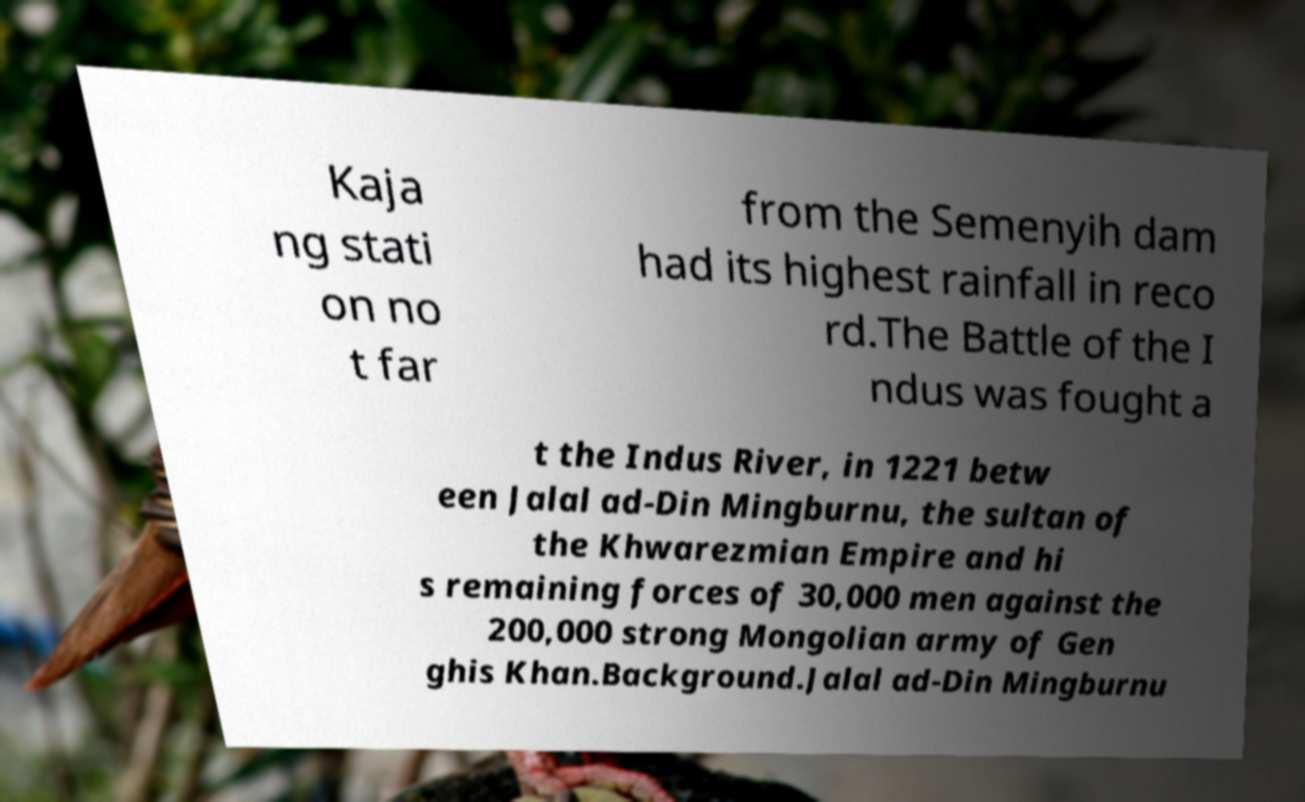I need the written content from this picture converted into text. Can you do that? Kaja ng stati on no t far from the Semenyih dam had its highest rainfall in reco rd.The Battle of the I ndus was fought a t the Indus River, in 1221 betw een Jalal ad-Din Mingburnu, the sultan of the Khwarezmian Empire and hi s remaining forces of 30,000 men against the 200,000 strong Mongolian army of Gen ghis Khan.Background.Jalal ad-Din Mingburnu 